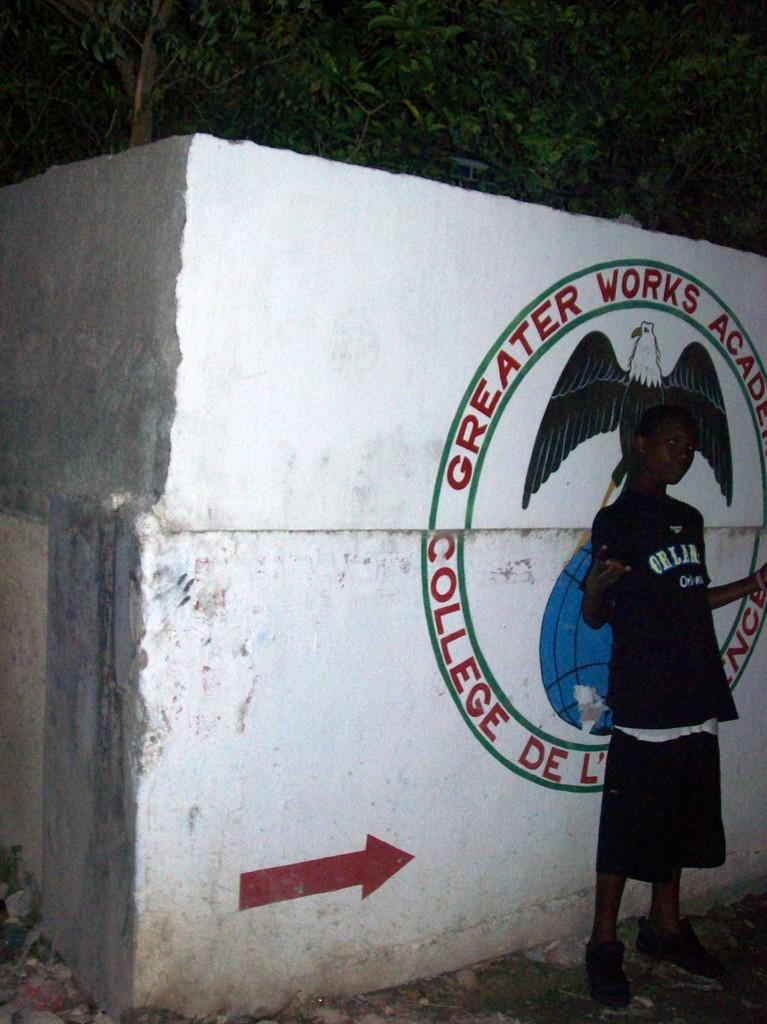<image>
Provide a brief description of the given image. Boy standing in front of a wall which says "greater works academy". 